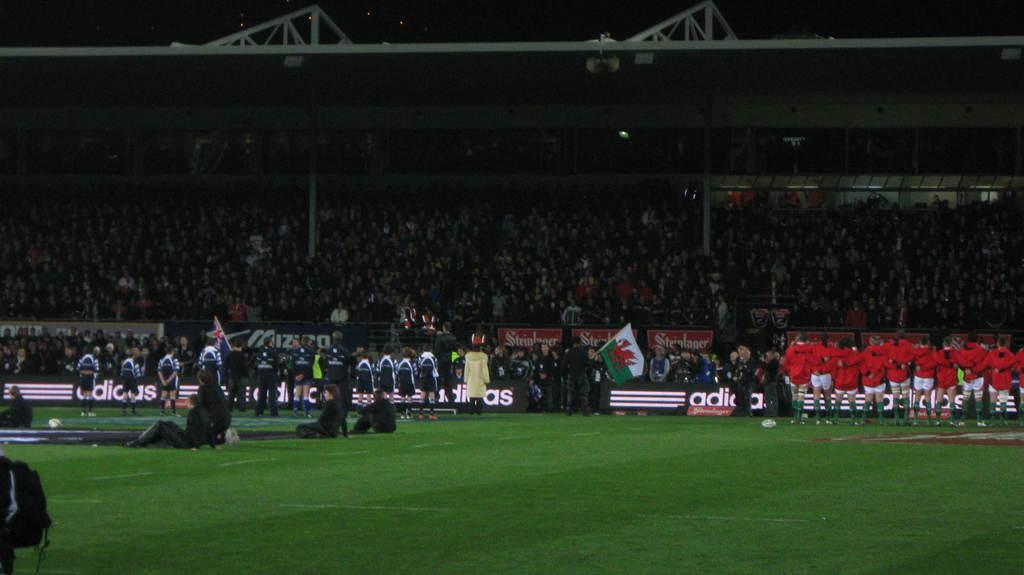What is located at the top of the image? There is an iron grill, speakers, and spectators at the top of the image. What is located at the bottom of the image? There is a crowd, an advertisement, a flag, and ground visible at the bottom of the image. What can be seen in the image that might be used for amplifying sound? There are speakers at the top of the image. What might be used for displaying information or advertising in the image? There is an advertisement at the bottom of the image. Can you hear the squirrel crying in the image? There is no squirrel or crying sound present in the image. How does the earthquake affect the iron grill in the image? There is no earthquake present in the image, so it cannot affect the iron grill. 